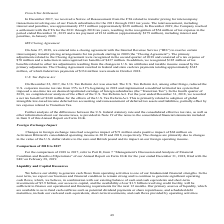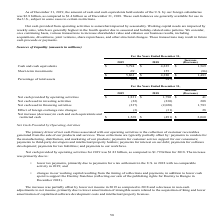According to Activision Blizzard's financial document, According to the company, what are working capital needs impacted by? According to the financial document, weekly sales. The relevant text states: "weekly sales, which are generally highest in the fourth quarter due to seasonal and holiday-related sales patter..." Also, What was the Net cash provided by operating activities in 2019? According to the financial document, $1,831 (in millions). The relevant text states: "Net cash provided by operating activities $ 1,831 $ 1,790 $ 41..." Also, What was the Net cash provided by operating activities in 2018? According to the financial document, $1,790 (in millions). The relevant text states: "t cash provided by operating activities $ 1,831 $ 1,790 $ 41..." Also, can you calculate: What was the percentage change in Net cash provided by operating activities between 2018 and 2019? To answer this question, I need to perform calculations using the financial data. The calculation is: ($1,831-$1,790)/$1,790, which equals 2.29 (percentage). This is based on the information: "Net cash provided by operating activities $ 1,831 $ 1,790 $ 41 t cash provided by operating activities $ 1,831 $ 1,790 $ 41..." The key data points involved are: 1,790, 1,831. Also, can you calculate: What is the increase(decrease) in Net cash provided by operating activities as a percentage of Increase (Decrease) of Net cash used in investing activities? Based on the calculation: 41/208, the result is 19.71 (percentage). This is based on the information: "rovided by operating activities $ 1,831 $ 1,790 $ 41 Net cash used in investing activities (22) (230) 208..." The key data points involved are: 208, 41. Also, can you calculate: What is the increase(decrease) in Net cash provided by operating activities as a percentage of Increase (Decrease) in Net cash used in financing activities? Based on the calculation: 41/1,783, the result is 2.3 (percentage). This is based on the information: "rovided by operating activities $ 1,831 $ 1,790 $ 41 t cash used in financing activities (237) (2,020) 1,783..." The key data points involved are: 1,783, 41. 